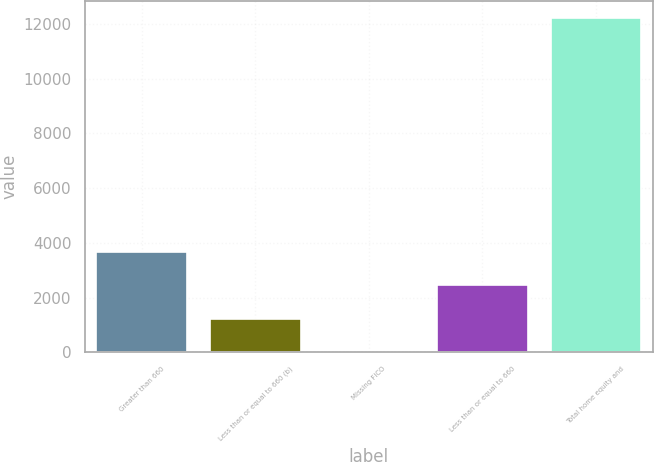Convert chart to OTSL. <chart><loc_0><loc_0><loc_500><loc_500><bar_chart><fcel>Greater than 660<fcel>Less than or equal to 660 (b)<fcel>Missing FICO<fcel>Less than or equal to 660<fcel>Total home equity and<nl><fcel>3674.7<fcel>1230.9<fcel>9<fcel>2452.8<fcel>12228<nl></chart> 